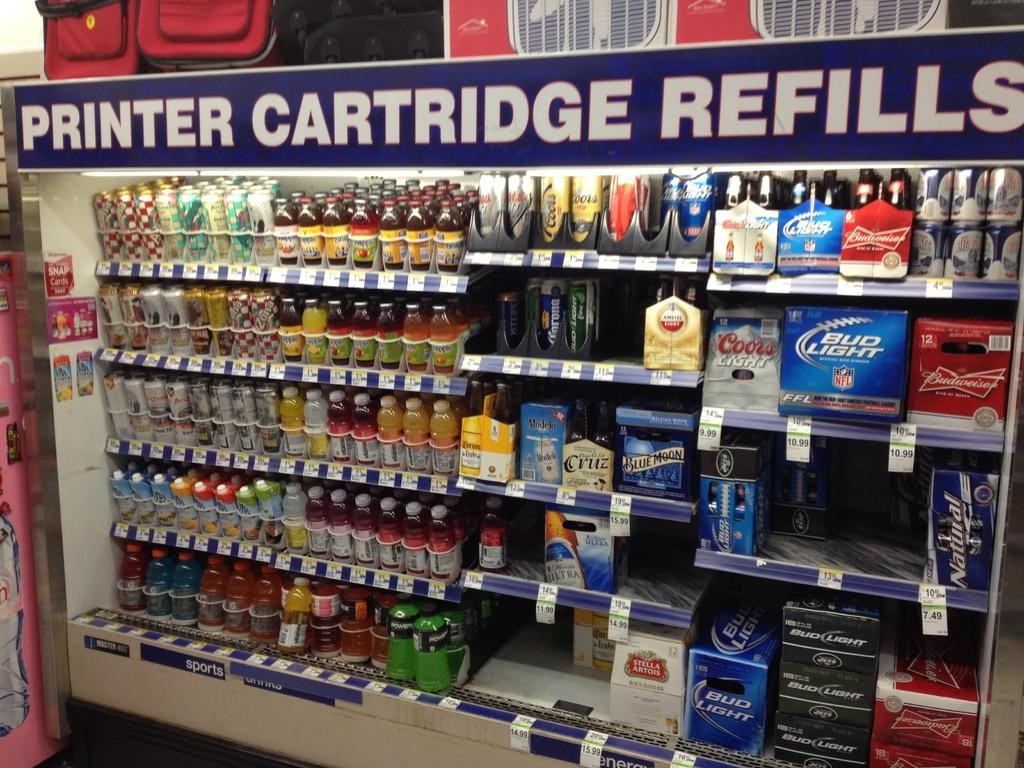Provide a one-sentence caption for the provided image. An cooler aisle in a store says Printer Cartridge Refills and has beverages in it. 